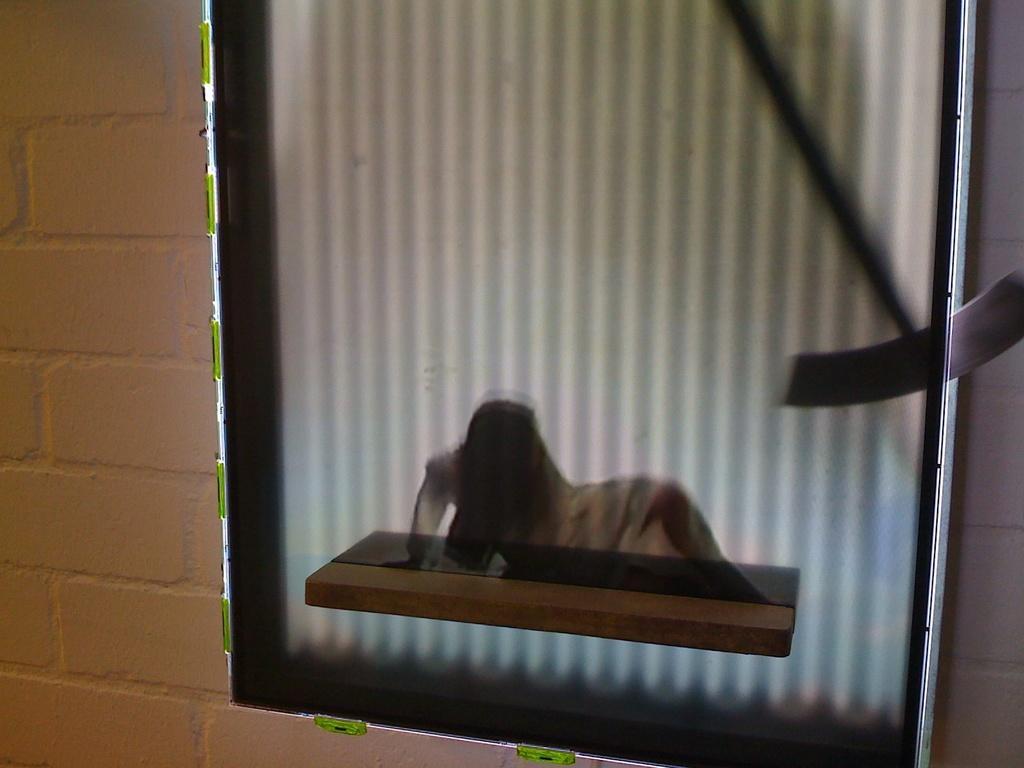Please provide a concise description of this image. In this image we can see the mirror on the wall and this is a wall. 